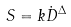<formula> <loc_0><loc_0><loc_500><loc_500>S = k \dot { D } ^ { \Delta }</formula> 